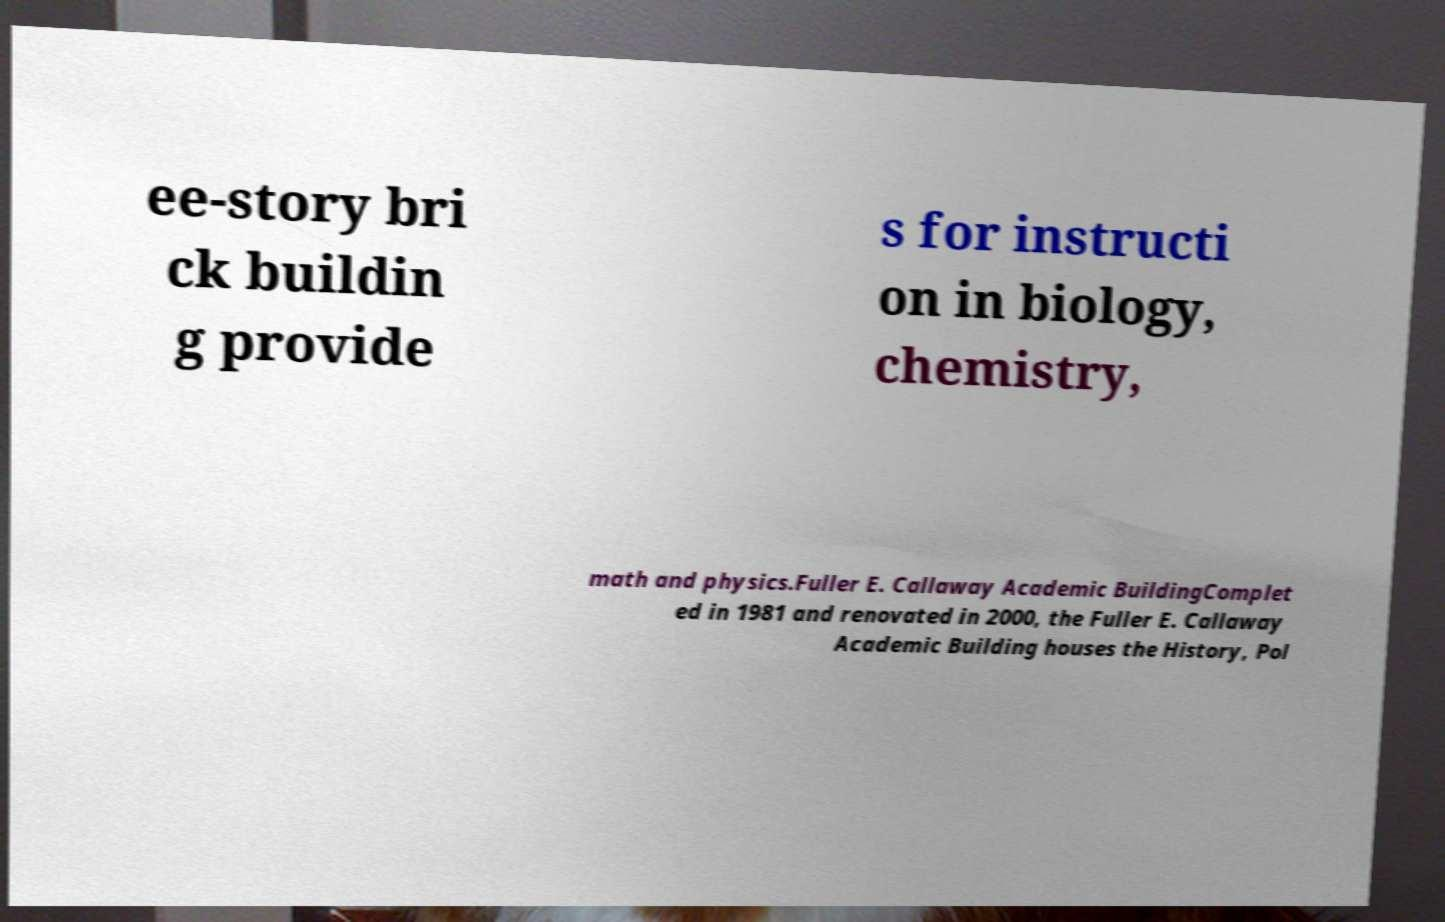Please read and relay the text visible in this image. What does it say? ee-story bri ck buildin g provide s for instructi on in biology, chemistry, math and physics.Fuller E. Callaway Academic BuildingComplet ed in 1981 and renovated in 2000, the Fuller E. Callaway Academic Building houses the History, Pol 